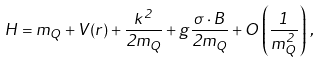Convert formula to latex. <formula><loc_0><loc_0><loc_500><loc_500>H = m _ { Q } + V ( { r } ) + \frac { { k } ^ { 2 } } { 2 m _ { Q } } + g \frac { { \sigma } \cdot { B } } { 2 m _ { Q } } + O \left ( \frac { 1 } { m _ { Q } ^ { 2 } } \right ) \, ,</formula> 